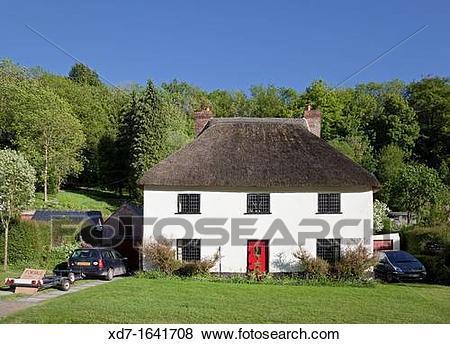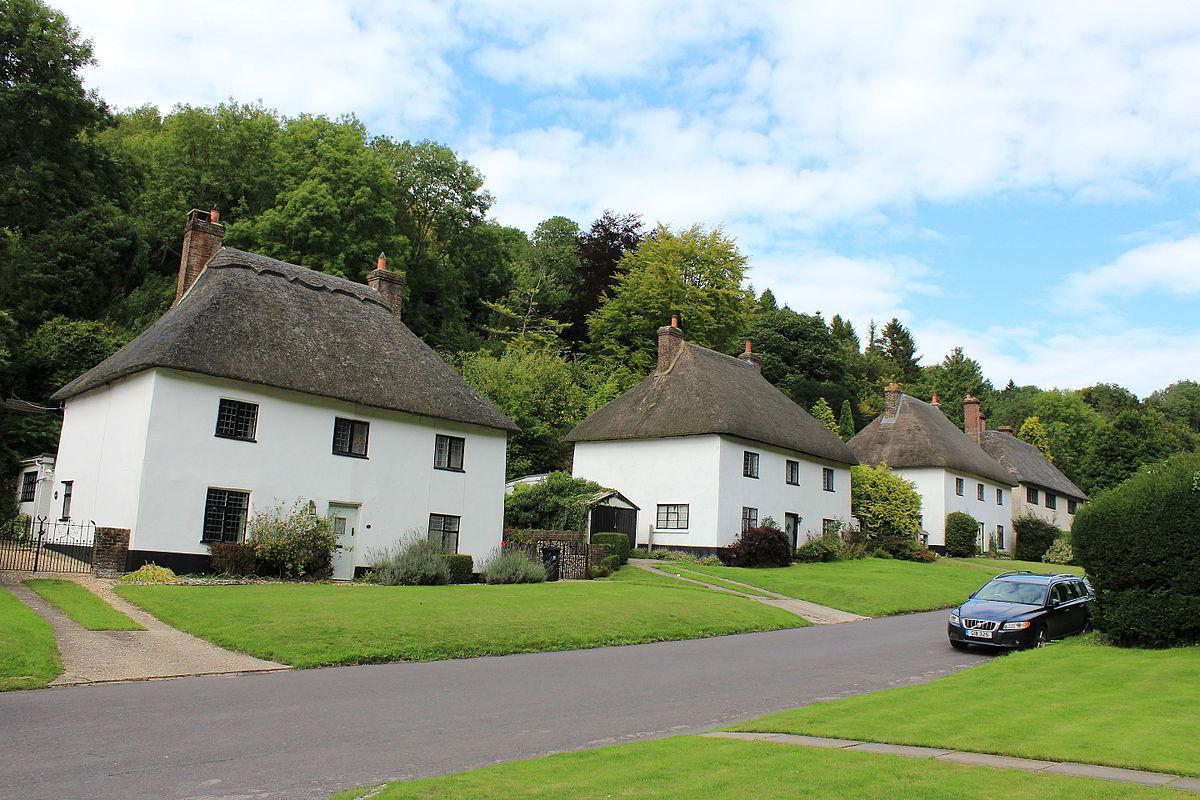The first image is the image on the left, the second image is the image on the right. Examine the images to the left and right. Is the description "One image shows a row of at least four rectangular white buildings with dark gray roofs to the left of a paved road, and the other image shows one rectangular white building with a dark gray roof." accurate? Answer yes or no. Yes. The first image is the image on the left, the second image is the image on the right. Considering the images on both sides, is "A street passes near a row of houses in the image on the left." valid? Answer yes or no. No. 